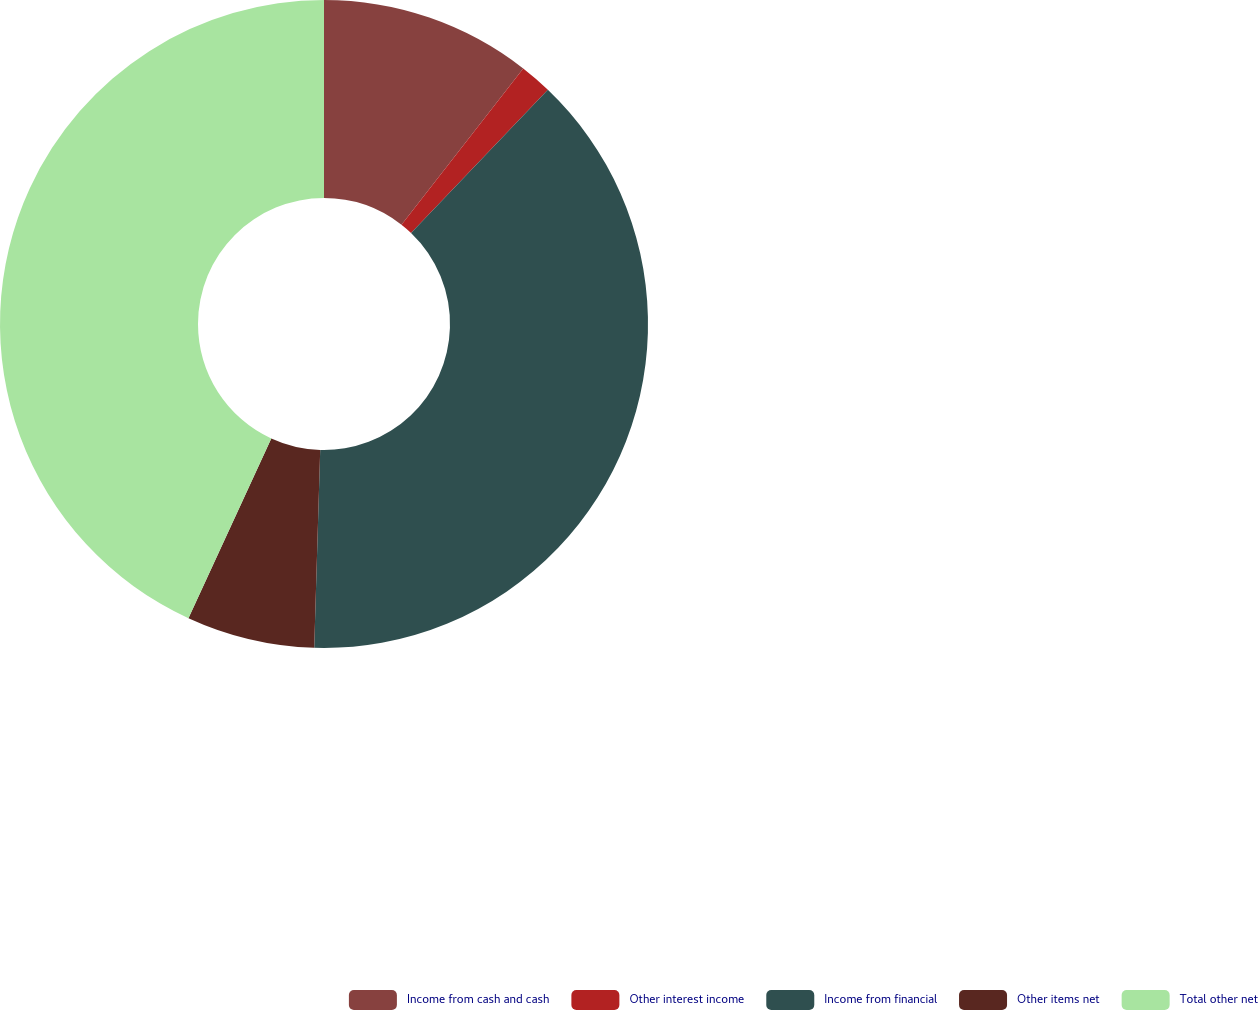<chart> <loc_0><loc_0><loc_500><loc_500><pie_chart><fcel>Income from cash and cash<fcel>Other interest income<fcel>Income from financial<fcel>Other items net<fcel>Total other net<nl><fcel>10.54%<fcel>1.6%<fcel>38.34%<fcel>6.39%<fcel>43.13%<nl></chart> 